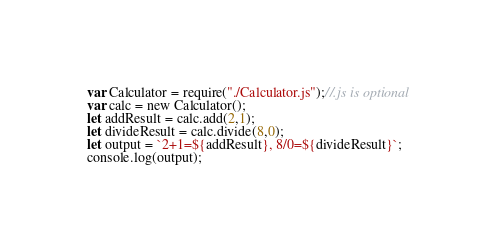Convert code to text. <code><loc_0><loc_0><loc_500><loc_500><_JavaScript_>var Calculator = require("./Calculator.js");//.js is optional
var calc = new Calculator();
let addResult = calc.add(2,1);
let divideResult = calc.divide(8,0);
let output = `2+1=${addResult}, 8/0=${divideResult}`;
console.log(output);










</code> 